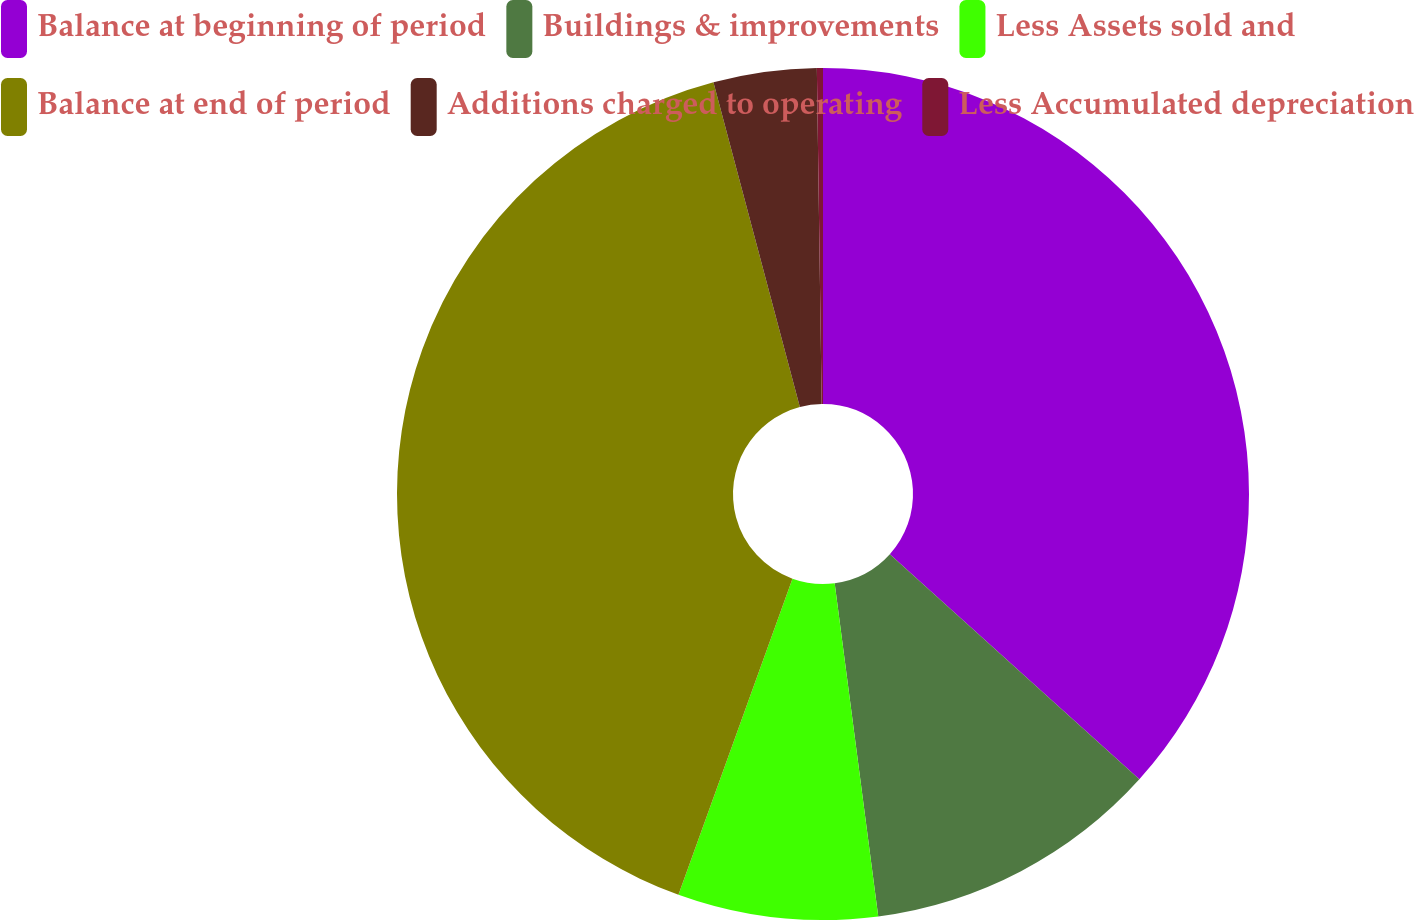<chart> <loc_0><loc_0><loc_500><loc_500><pie_chart><fcel>Balance at beginning of period<fcel>Buildings & improvements<fcel>Less Assets sold and<fcel>Balance at end of period<fcel>Additions charged to operating<fcel>Less Accumulated depreciation<nl><fcel>36.68%<fcel>11.25%<fcel>7.58%<fcel>40.35%<fcel>3.91%<fcel>0.23%<nl></chart> 